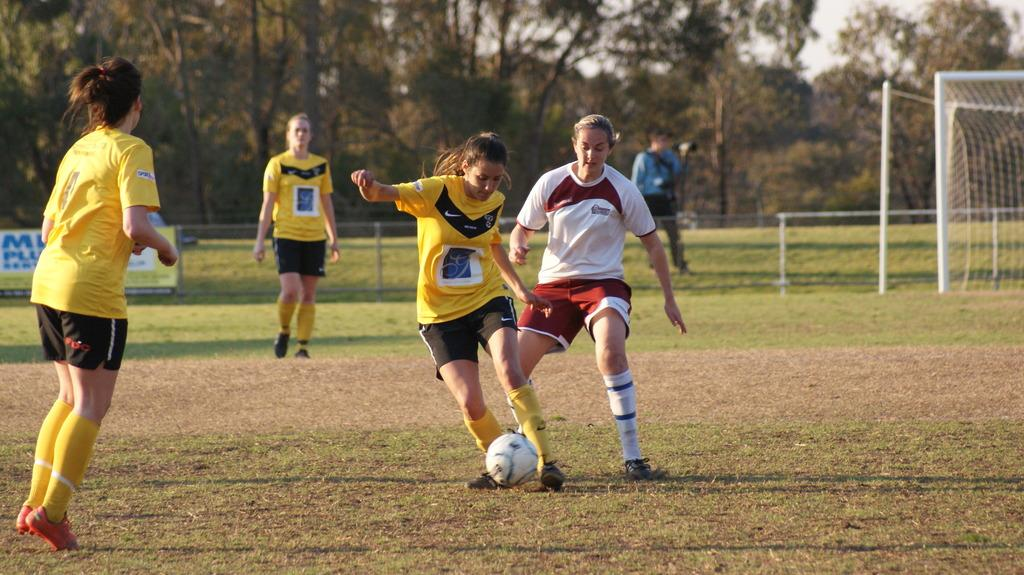What type of landscape is visible in the image? There is a field in the image. How many sports people are present in the image? There are four sports people in the image. What object is associated with the sports people in the image? There is a ball in the image. What color is the paint on the hill in the image? There is no hill or paint present in the image. How many crows are visible in the image? There are no crows visible in the image. 